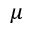Convert formula to latex. <formula><loc_0><loc_0><loc_500><loc_500>\mu</formula> 